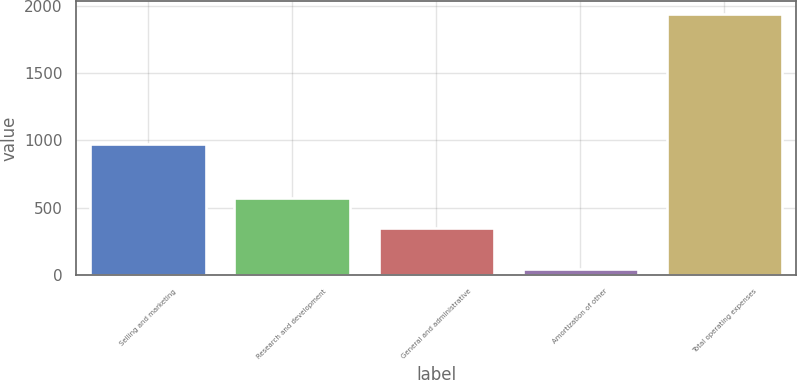Convert chart to OTSL. <chart><loc_0><loc_0><loc_500><loc_500><bar_chart><fcel>Selling and marketing<fcel>Research and development<fcel>General and administrative<fcel>Amortization of other<fcel>Total operating expenses<nl><fcel>976<fcel>573<fcel>348<fcel>42<fcel>1939<nl></chart> 